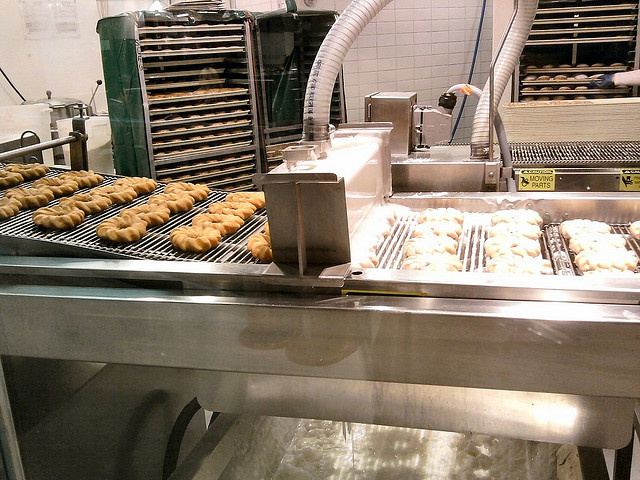Describe the objects in this image and their specific colors. I can see oven in beige, black, and tan tones, donut in beige, ivory, and tan tones, donut in beige, tan, olive, and maroon tones, donut in beige, tan, olive, and maroon tones, and donut in beige, tan, olive, and black tones in this image. 